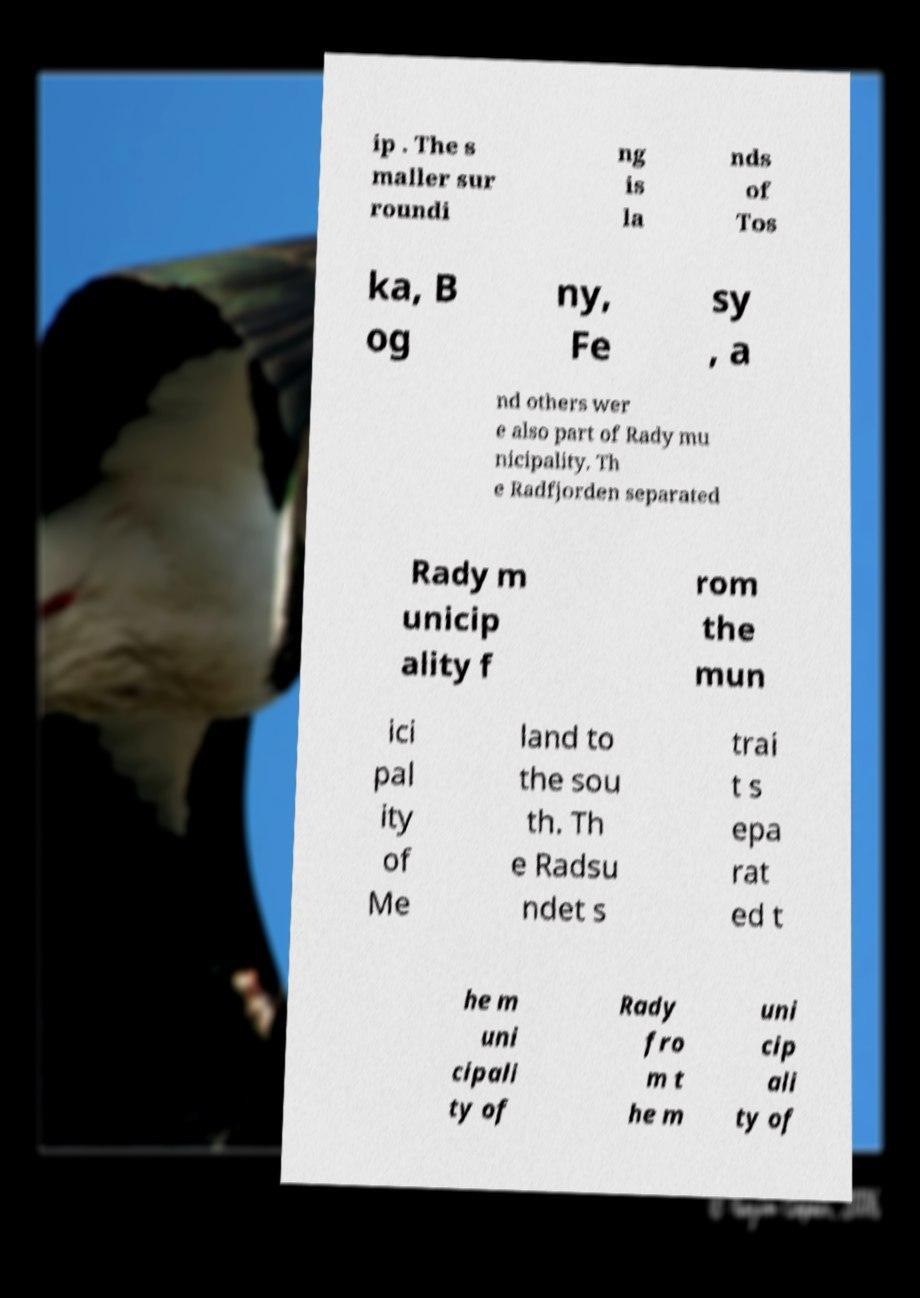For documentation purposes, I need the text within this image transcribed. Could you provide that? ip . The s maller sur roundi ng is la nds of Tos ka, B og ny, Fe sy , a nd others wer e also part of Rady mu nicipality. Th e Radfjorden separated Rady m unicip ality f rom the mun ici pal ity of Me land to the sou th. Th e Radsu ndet s trai t s epa rat ed t he m uni cipali ty of Rady fro m t he m uni cip ali ty of 